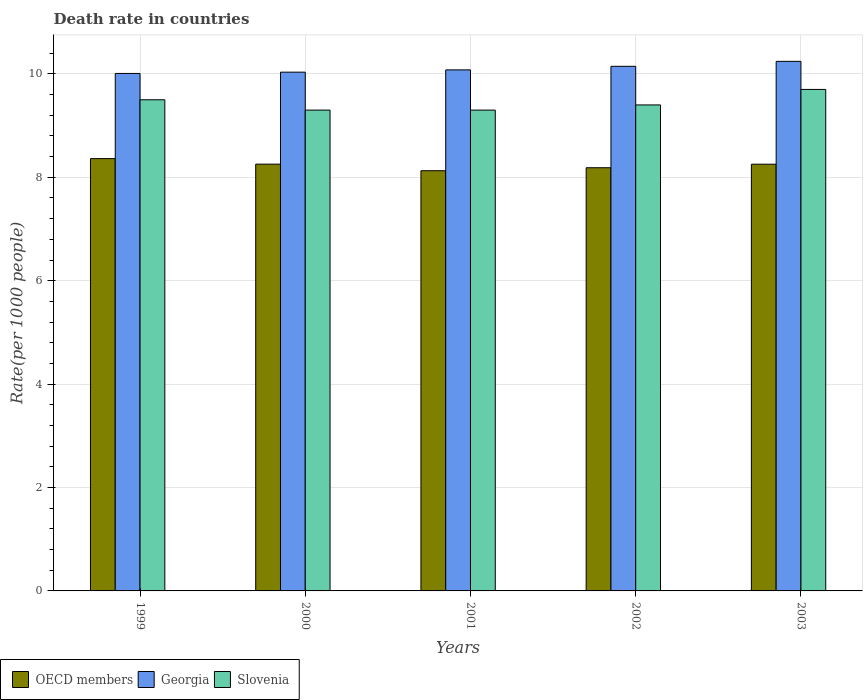Are the number of bars per tick equal to the number of legend labels?
Provide a succinct answer. Yes. How many bars are there on the 3rd tick from the left?
Your answer should be compact. 3. What is the label of the 3rd group of bars from the left?
Offer a terse response. 2001. What is the death rate in OECD members in 2003?
Provide a succinct answer. 8.25. Across all years, what is the minimum death rate in Georgia?
Give a very brief answer. 10.01. In which year was the death rate in OECD members maximum?
Keep it short and to the point. 1999. What is the total death rate in Georgia in the graph?
Provide a succinct answer. 50.51. What is the difference between the death rate in Slovenia in 1999 and that in 2000?
Offer a terse response. 0.2. What is the difference between the death rate in OECD members in 2000 and the death rate in Slovenia in 2002?
Provide a short and direct response. -1.15. What is the average death rate in OECD members per year?
Offer a terse response. 8.24. In the year 2000, what is the difference between the death rate in Slovenia and death rate in Georgia?
Provide a short and direct response. -0.73. In how many years, is the death rate in Georgia greater than 0.4?
Ensure brevity in your answer.  5. What is the ratio of the death rate in Slovenia in 1999 to that in 2001?
Keep it short and to the point. 1.02. Is the death rate in OECD members in 2001 less than that in 2002?
Provide a short and direct response. Yes. Is the difference between the death rate in Slovenia in 1999 and 2001 greater than the difference between the death rate in Georgia in 1999 and 2001?
Offer a very short reply. Yes. What is the difference between the highest and the second highest death rate in Georgia?
Offer a very short reply. 0.1. What is the difference between the highest and the lowest death rate in Georgia?
Provide a short and direct response. 0.23. In how many years, is the death rate in Slovenia greater than the average death rate in Slovenia taken over all years?
Keep it short and to the point. 2. Is the sum of the death rate in OECD members in 2001 and 2002 greater than the maximum death rate in Slovenia across all years?
Provide a succinct answer. Yes. What does the 2nd bar from the left in 2003 represents?
Ensure brevity in your answer.  Georgia. What does the 1st bar from the right in 2003 represents?
Offer a terse response. Slovenia. Is it the case that in every year, the sum of the death rate in Georgia and death rate in Slovenia is greater than the death rate in OECD members?
Your answer should be very brief. Yes. Are all the bars in the graph horizontal?
Provide a short and direct response. No. How many years are there in the graph?
Make the answer very short. 5. Are the values on the major ticks of Y-axis written in scientific E-notation?
Give a very brief answer. No. Does the graph contain any zero values?
Keep it short and to the point. No. Where does the legend appear in the graph?
Your answer should be compact. Bottom left. How many legend labels are there?
Provide a short and direct response. 3. How are the legend labels stacked?
Ensure brevity in your answer.  Horizontal. What is the title of the graph?
Offer a terse response. Death rate in countries. Does "OECD members" appear as one of the legend labels in the graph?
Make the answer very short. Yes. What is the label or title of the Y-axis?
Keep it short and to the point. Rate(per 1000 people). What is the Rate(per 1000 people) of OECD members in 1999?
Give a very brief answer. 8.36. What is the Rate(per 1000 people) of Georgia in 1999?
Your answer should be compact. 10.01. What is the Rate(per 1000 people) of OECD members in 2000?
Your response must be concise. 8.25. What is the Rate(per 1000 people) of Georgia in 2000?
Make the answer very short. 10.03. What is the Rate(per 1000 people) of OECD members in 2001?
Offer a terse response. 8.13. What is the Rate(per 1000 people) of Georgia in 2001?
Your response must be concise. 10.08. What is the Rate(per 1000 people) in OECD members in 2002?
Ensure brevity in your answer.  8.19. What is the Rate(per 1000 people) in Georgia in 2002?
Your answer should be compact. 10.15. What is the Rate(per 1000 people) in Slovenia in 2002?
Give a very brief answer. 9.4. What is the Rate(per 1000 people) of OECD members in 2003?
Make the answer very short. 8.25. What is the Rate(per 1000 people) in Georgia in 2003?
Your response must be concise. 10.24. What is the Rate(per 1000 people) of Slovenia in 2003?
Give a very brief answer. 9.7. Across all years, what is the maximum Rate(per 1000 people) of OECD members?
Give a very brief answer. 8.36. Across all years, what is the maximum Rate(per 1000 people) in Georgia?
Ensure brevity in your answer.  10.24. Across all years, what is the minimum Rate(per 1000 people) of OECD members?
Offer a very short reply. 8.13. Across all years, what is the minimum Rate(per 1000 people) of Georgia?
Provide a succinct answer. 10.01. Across all years, what is the minimum Rate(per 1000 people) of Slovenia?
Your response must be concise. 9.3. What is the total Rate(per 1000 people) of OECD members in the graph?
Offer a very short reply. 41.18. What is the total Rate(per 1000 people) in Georgia in the graph?
Keep it short and to the point. 50.51. What is the total Rate(per 1000 people) in Slovenia in the graph?
Ensure brevity in your answer.  47.2. What is the difference between the Rate(per 1000 people) in OECD members in 1999 and that in 2000?
Your response must be concise. 0.11. What is the difference between the Rate(per 1000 people) of Georgia in 1999 and that in 2000?
Your answer should be compact. -0.03. What is the difference between the Rate(per 1000 people) of Slovenia in 1999 and that in 2000?
Your answer should be compact. 0.2. What is the difference between the Rate(per 1000 people) of OECD members in 1999 and that in 2001?
Provide a succinct answer. 0.23. What is the difference between the Rate(per 1000 people) in Georgia in 1999 and that in 2001?
Your answer should be very brief. -0.07. What is the difference between the Rate(per 1000 people) of OECD members in 1999 and that in 2002?
Give a very brief answer. 0.18. What is the difference between the Rate(per 1000 people) of Georgia in 1999 and that in 2002?
Make the answer very short. -0.14. What is the difference between the Rate(per 1000 people) in OECD members in 1999 and that in 2003?
Your response must be concise. 0.11. What is the difference between the Rate(per 1000 people) in Georgia in 1999 and that in 2003?
Offer a very short reply. -0.23. What is the difference between the Rate(per 1000 people) of Slovenia in 1999 and that in 2003?
Provide a succinct answer. -0.2. What is the difference between the Rate(per 1000 people) in OECD members in 2000 and that in 2001?
Make the answer very short. 0.13. What is the difference between the Rate(per 1000 people) of Georgia in 2000 and that in 2001?
Keep it short and to the point. -0.04. What is the difference between the Rate(per 1000 people) in OECD members in 2000 and that in 2002?
Make the answer very short. 0.07. What is the difference between the Rate(per 1000 people) of Georgia in 2000 and that in 2002?
Give a very brief answer. -0.11. What is the difference between the Rate(per 1000 people) in OECD members in 2000 and that in 2003?
Offer a terse response. 0. What is the difference between the Rate(per 1000 people) in Georgia in 2000 and that in 2003?
Keep it short and to the point. -0.21. What is the difference between the Rate(per 1000 people) in OECD members in 2001 and that in 2002?
Make the answer very short. -0.06. What is the difference between the Rate(per 1000 people) in Georgia in 2001 and that in 2002?
Ensure brevity in your answer.  -0.07. What is the difference between the Rate(per 1000 people) of Slovenia in 2001 and that in 2002?
Keep it short and to the point. -0.1. What is the difference between the Rate(per 1000 people) in OECD members in 2001 and that in 2003?
Keep it short and to the point. -0.13. What is the difference between the Rate(per 1000 people) of Georgia in 2001 and that in 2003?
Provide a succinct answer. -0.17. What is the difference between the Rate(per 1000 people) of Slovenia in 2001 and that in 2003?
Make the answer very short. -0.4. What is the difference between the Rate(per 1000 people) in OECD members in 2002 and that in 2003?
Keep it short and to the point. -0.07. What is the difference between the Rate(per 1000 people) in Georgia in 2002 and that in 2003?
Offer a terse response. -0.1. What is the difference between the Rate(per 1000 people) in OECD members in 1999 and the Rate(per 1000 people) in Georgia in 2000?
Your answer should be very brief. -1.67. What is the difference between the Rate(per 1000 people) in OECD members in 1999 and the Rate(per 1000 people) in Slovenia in 2000?
Make the answer very short. -0.94. What is the difference between the Rate(per 1000 people) in Georgia in 1999 and the Rate(per 1000 people) in Slovenia in 2000?
Give a very brief answer. 0.71. What is the difference between the Rate(per 1000 people) of OECD members in 1999 and the Rate(per 1000 people) of Georgia in 2001?
Ensure brevity in your answer.  -1.72. What is the difference between the Rate(per 1000 people) of OECD members in 1999 and the Rate(per 1000 people) of Slovenia in 2001?
Your response must be concise. -0.94. What is the difference between the Rate(per 1000 people) in Georgia in 1999 and the Rate(per 1000 people) in Slovenia in 2001?
Provide a short and direct response. 0.71. What is the difference between the Rate(per 1000 people) of OECD members in 1999 and the Rate(per 1000 people) of Georgia in 2002?
Give a very brief answer. -1.79. What is the difference between the Rate(per 1000 people) of OECD members in 1999 and the Rate(per 1000 people) of Slovenia in 2002?
Offer a terse response. -1.04. What is the difference between the Rate(per 1000 people) in Georgia in 1999 and the Rate(per 1000 people) in Slovenia in 2002?
Ensure brevity in your answer.  0.61. What is the difference between the Rate(per 1000 people) of OECD members in 1999 and the Rate(per 1000 people) of Georgia in 2003?
Your response must be concise. -1.88. What is the difference between the Rate(per 1000 people) of OECD members in 1999 and the Rate(per 1000 people) of Slovenia in 2003?
Keep it short and to the point. -1.34. What is the difference between the Rate(per 1000 people) of Georgia in 1999 and the Rate(per 1000 people) of Slovenia in 2003?
Offer a terse response. 0.31. What is the difference between the Rate(per 1000 people) in OECD members in 2000 and the Rate(per 1000 people) in Georgia in 2001?
Ensure brevity in your answer.  -1.82. What is the difference between the Rate(per 1000 people) in OECD members in 2000 and the Rate(per 1000 people) in Slovenia in 2001?
Give a very brief answer. -1.05. What is the difference between the Rate(per 1000 people) in Georgia in 2000 and the Rate(per 1000 people) in Slovenia in 2001?
Provide a short and direct response. 0.73. What is the difference between the Rate(per 1000 people) of OECD members in 2000 and the Rate(per 1000 people) of Georgia in 2002?
Offer a terse response. -1.89. What is the difference between the Rate(per 1000 people) in OECD members in 2000 and the Rate(per 1000 people) in Slovenia in 2002?
Keep it short and to the point. -1.15. What is the difference between the Rate(per 1000 people) in Georgia in 2000 and the Rate(per 1000 people) in Slovenia in 2002?
Offer a very short reply. 0.63. What is the difference between the Rate(per 1000 people) in OECD members in 2000 and the Rate(per 1000 people) in Georgia in 2003?
Your response must be concise. -1.99. What is the difference between the Rate(per 1000 people) of OECD members in 2000 and the Rate(per 1000 people) of Slovenia in 2003?
Your answer should be compact. -1.45. What is the difference between the Rate(per 1000 people) in Georgia in 2000 and the Rate(per 1000 people) in Slovenia in 2003?
Make the answer very short. 0.33. What is the difference between the Rate(per 1000 people) of OECD members in 2001 and the Rate(per 1000 people) of Georgia in 2002?
Give a very brief answer. -2.02. What is the difference between the Rate(per 1000 people) in OECD members in 2001 and the Rate(per 1000 people) in Slovenia in 2002?
Provide a succinct answer. -1.27. What is the difference between the Rate(per 1000 people) of Georgia in 2001 and the Rate(per 1000 people) of Slovenia in 2002?
Give a very brief answer. 0.68. What is the difference between the Rate(per 1000 people) of OECD members in 2001 and the Rate(per 1000 people) of Georgia in 2003?
Your answer should be very brief. -2.12. What is the difference between the Rate(per 1000 people) of OECD members in 2001 and the Rate(per 1000 people) of Slovenia in 2003?
Provide a succinct answer. -1.57. What is the difference between the Rate(per 1000 people) in Georgia in 2001 and the Rate(per 1000 people) in Slovenia in 2003?
Provide a succinct answer. 0.38. What is the difference between the Rate(per 1000 people) of OECD members in 2002 and the Rate(per 1000 people) of Georgia in 2003?
Offer a very short reply. -2.06. What is the difference between the Rate(per 1000 people) of OECD members in 2002 and the Rate(per 1000 people) of Slovenia in 2003?
Your answer should be compact. -1.51. What is the difference between the Rate(per 1000 people) of Georgia in 2002 and the Rate(per 1000 people) of Slovenia in 2003?
Make the answer very short. 0.45. What is the average Rate(per 1000 people) of OECD members per year?
Provide a succinct answer. 8.24. What is the average Rate(per 1000 people) in Georgia per year?
Your answer should be very brief. 10.1. What is the average Rate(per 1000 people) in Slovenia per year?
Provide a short and direct response. 9.44. In the year 1999, what is the difference between the Rate(per 1000 people) in OECD members and Rate(per 1000 people) in Georgia?
Your answer should be very brief. -1.65. In the year 1999, what is the difference between the Rate(per 1000 people) of OECD members and Rate(per 1000 people) of Slovenia?
Make the answer very short. -1.14. In the year 1999, what is the difference between the Rate(per 1000 people) of Georgia and Rate(per 1000 people) of Slovenia?
Keep it short and to the point. 0.51. In the year 2000, what is the difference between the Rate(per 1000 people) in OECD members and Rate(per 1000 people) in Georgia?
Offer a very short reply. -1.78. In the year 2000, what is the difference between the Rate(per 1000 people) in OECD members and Rate(per 1000 people) in Slovenia?
Offer a terse response. -1.05. In the year 2000, what is the difference between the Rate(per 1000 people) of Georgia and Rate(per 1000 people) of Slovenia?
Ensure brevity in your answer.  0.73. In the year 2001, what is the difference between the Rate(per 1000 people) of OECD members and Rate(per 1000 people) of Georgia?
Give a very brief answer. -1.95. In the year 2001, what is the difference between the Rate(per 1000 people) of OECD members and Rate(per 1000 people) of Slovenia?
Your answer should be compact. -1.17. In the year 2001, what is the difference between the Rate(per 1000 people) of Georgia and Rate(per 1000 people) of Slovenia?
Offer a terse response. 0.78. In the year 2002, what is the difference between the Rate(per 1000 people) of OECD members and Rate(per 1000 people) of Georgia?
Give a very brief answer. -1.96. In the year 2002, what is the difference between the Rate(per 1000 people) of OECD members and Rate(per 1000 people) of Slovenia?
Give a very brief answer. -1.21. In the year 2002, what is the difference between the Rate(per 1000 people) in Georgia and Rate(per 1000 people) in Slovenia?
Offer a very short reply. 0.75. In the year 2003, what is the difference between the Rate(per 1000 people) of OECD members and Rate(per 1000 people) of Georgia?
Keep it short and to the point. -1.99. In the year 2003, what is the difference between the Rate(per 1000 people) in OECD members and Rate(per 1000 people) in Slovenia?
Offer a very short reply. -1.45. In the year 2003, what is the difference between the Rate(per 1000 people) in Georgia and Rate(per 1000 people) in Slovenia?
Make the answer very short. 0.54. What is the ratio of the Rate(per 1000 people) in OECD members in 1999 to that in 2000?
Offer a terse response. 1.01. What is the ratio of the Rate(per 1000 people) in Georgia in 1999 to that in 2000?
Provide a succinct answer. 1. What is the ratio of the Rate(per 1000 people) in Slovenia in 1999 to that in 2000?
Offer a terse response. 1.02. What is the ratio of the Rate(per 1000 people) of OECD members in 1999 to that in 2001?
Ensure brevity in your answer.  1.03. What is the ratio of the Rate(per 1000 people) in Georgia in 1999 to that in 2001?
Keep it short and to the point. 0.99. What is the ratio of the Rate(per 1000 people) of Slovenia in 1999 to that in 2001?
Offer a terse response. 1.02. What is the ratio of the Rate(per 1000 people) in OECD members in 1999 to that in 2002?
Your answer should be compact. 1.02. What is the ratio of the Rate(per 1000 people) in Georgia in 1999 to that in 2002?
Keep it short and to the point. 0.99. What is the ratio of the Rate(per 1000 people) in Slovenia in 1999 to that in 2002?
Ensure brevity in your answer.  1.01. What is the ratio of the Rate(per 1000 people) of OECD members in 1999 to that in 2003?
Offer a very short reply. 1.01. What is the ratio of the Rate(per 1000 people) of Georgia in 1999 to that in 2003?
Ensure brevity in your answer.  0.98. What is the ratio of the Rate(per 1000 people) of Slovenia in 1999 to that in 2003?
Offer a very short reply. 0.98. What is the ratio of the Rate(per 1000 people) of OECD members in 2000 to that in 2001?
Give a very brief answer. 1.02. What is the ratio of the Rate(per 1000 people) of Slovenia in 2000 to that in 2001?
Make the answer very short. 1. What is the ratio of the Rate(per 1000 people) of OECD members in 2000 to that in 2002?
Provide a short and direct response. 1.01. What is the ratio of the Rate(per 1000 people) of Georgia in 2000 to that in 2002?
Make the answer very short. 0.99. What is the ratio of the Rate(per 1000 people) in Georgia in 2000 to that in 2003?
Your response must be concise. 0.98. What is the ratio of the Rate(per 1000 people) in Slovenia in 2000 to that in 2003?
Ensure brevity in your answer.  0.96. What is the ratio of the Rate(per 1000 people) of OECD members in 2001 to that in 2003?
Your answer should be very brief. 0.98. What is the ratio of the Rate(per 1000 people) of Georgia in 2001 to that in 2003?
Ensure brevity in your answer.  0.98. What is the ratio of the Rate(per 1000 people) of Slovenia in 2001 to that in 2003?
Your response must be concise. 0.96. What is the ratio of the Rate(per 1000 people) of OECD members in 2002 to that in 2003?
Your response must be concise. 0.99. What is the ratio of the Rate(per 1000 people) in Georgia in 2002 to that in 2003?
Ensure brevity in your answer.  0.99. What is the ratio of the Rate(per 1000 people) in Slovenia in 2002 to that in 2003?
Give a very brief answer. 0.97. What is the difference between the highest and the second highest Rate(per 1000 people) of OECD members?
Your answer should be compact. 0.11. What is the difference between the highest and the second highest Rate(per 1000 people) in Georgia?
Give a very brief answer. 0.1. What is the difference between the highest and the lowest Rate(per 1000 people) in OECD members?
Provide a succinct answer. 0.23. What is the difference between the highest and the lowest Rate(per 1000 people) of Georgia?
Keep it short and to the point. 0.23. What is the difference between the highest and the lowest Rate(per 1000 people) in Slovenia?
Your answer should be compact. 0.4. 